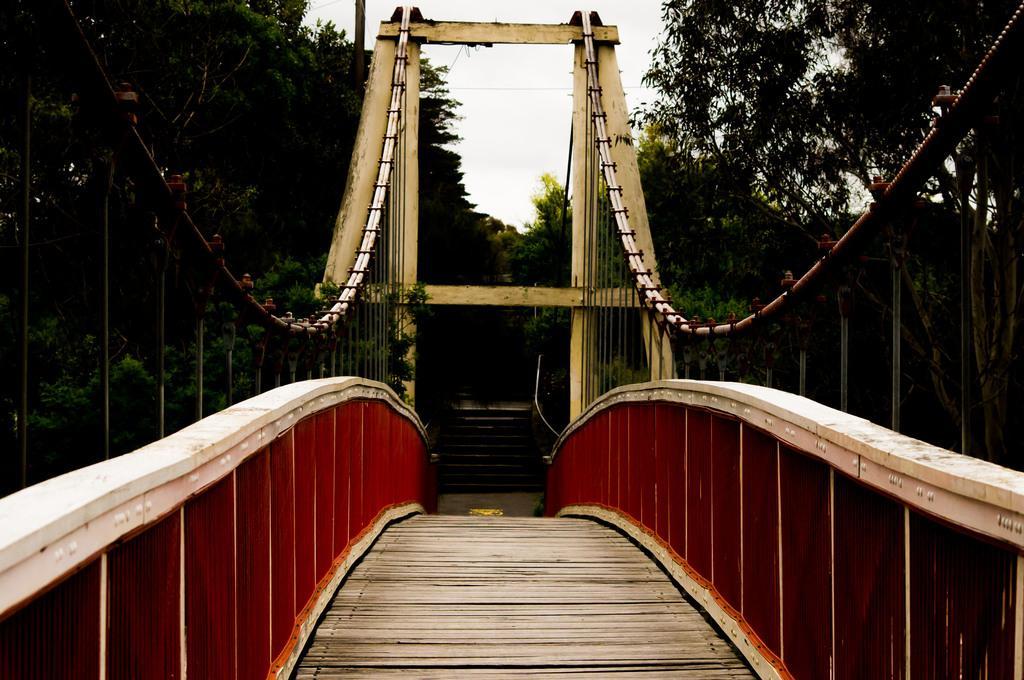In one or two sentences, can you explain what this image depicts? In this image there is a bridge, staircase, trees,sky. 